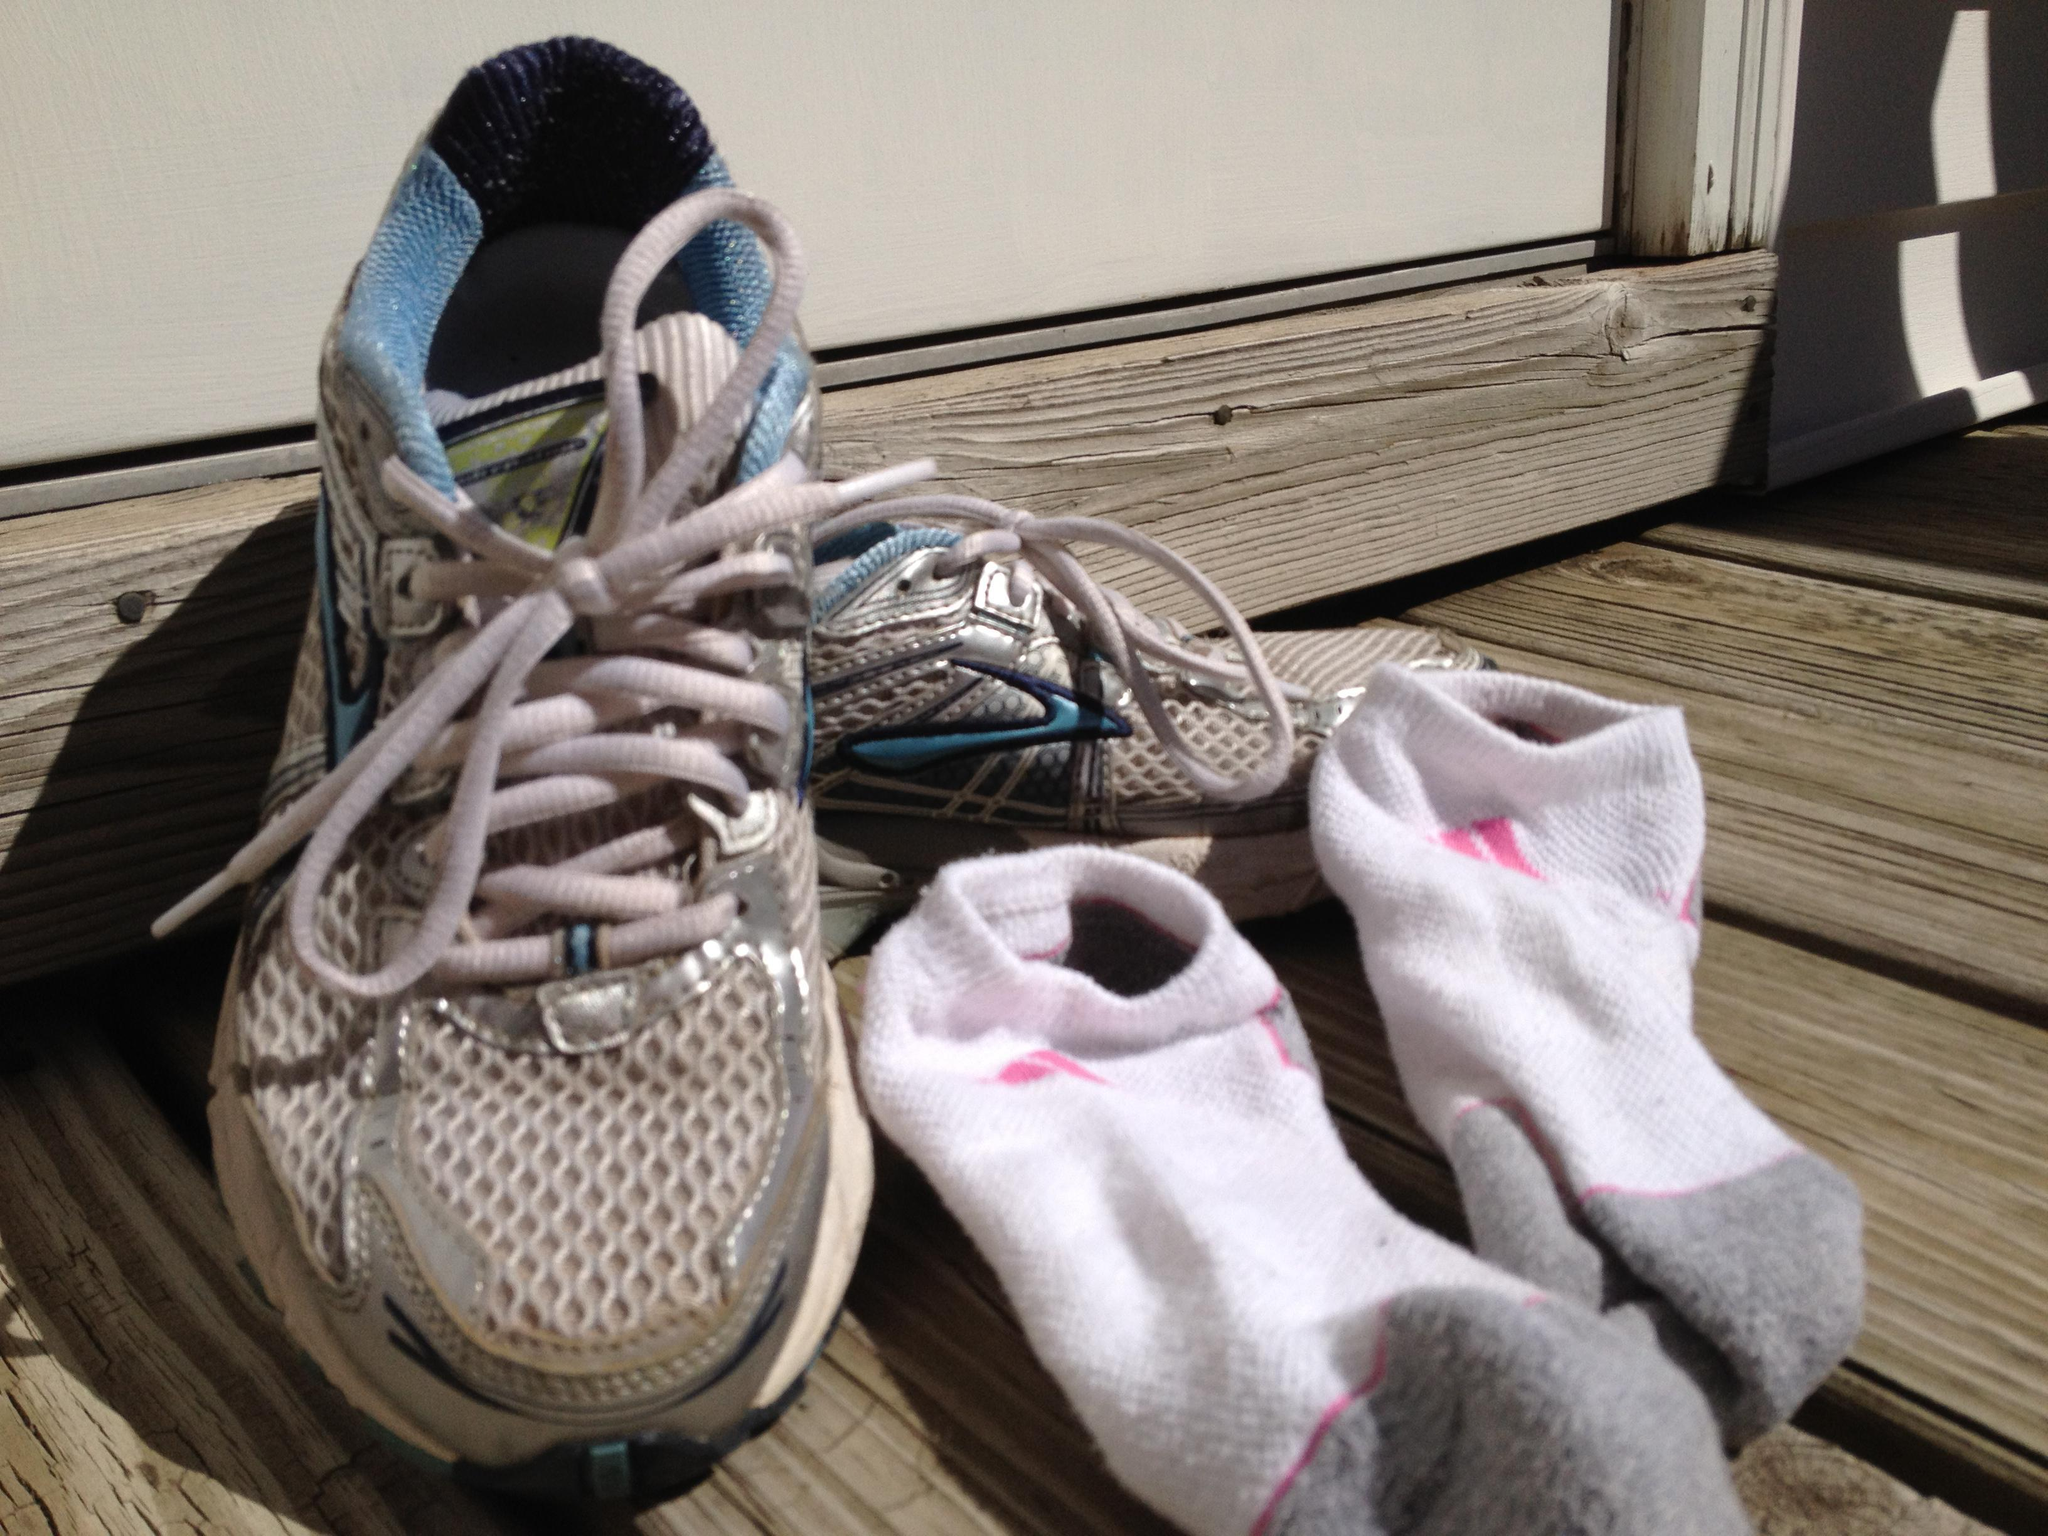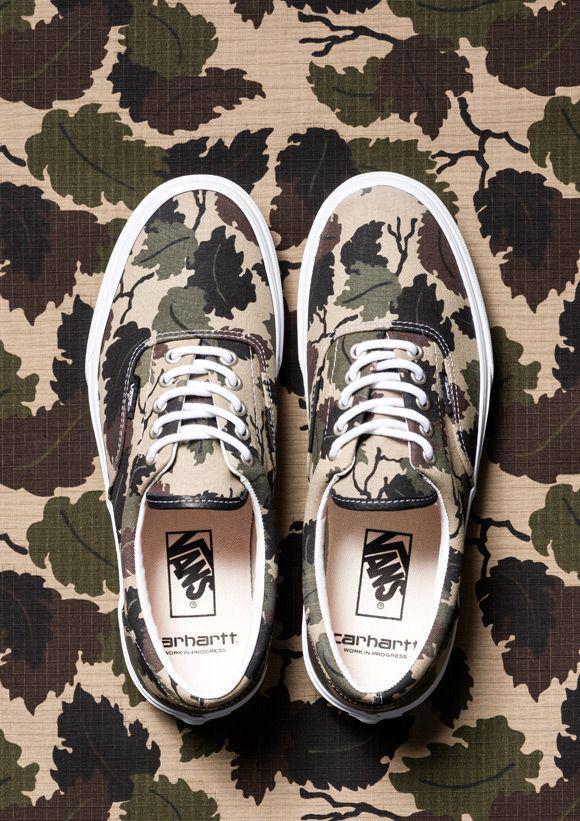The first image is the image on the left, the second image is the image on the right. For the images shown, is this caption "Some sneakers are brand new and some are not." true? Answer yes or no. Yes. The first image is the image on the left, the second image is the image on the right. Analyze the images presented: Is the assertion "There are at least four pairs of shoes." valid? Answer yes or no. No. 